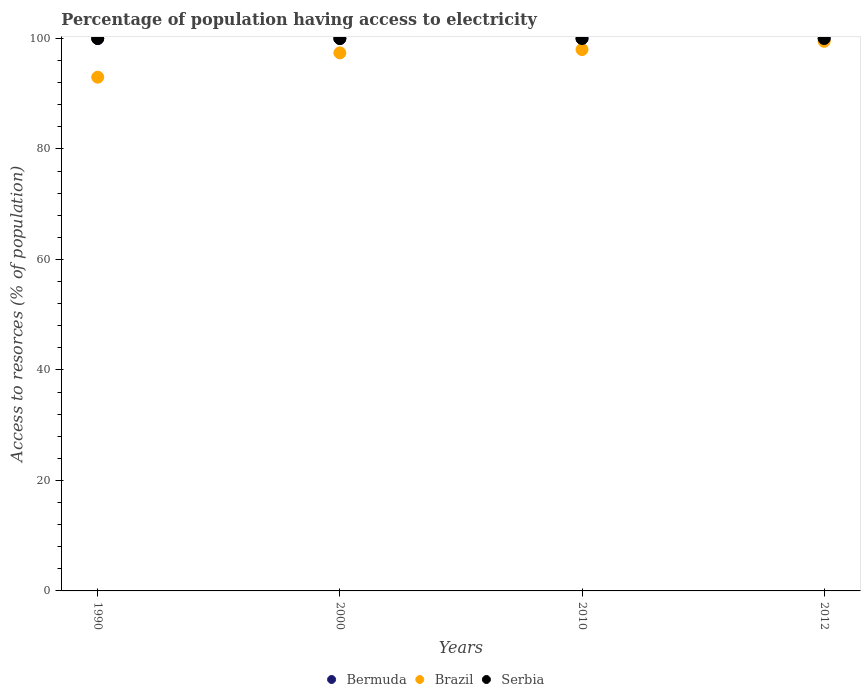How many different coloured dotlines are there?
Your answer should be very brief. 3. Is the number of dotlines equal to the number of legend labels?
Offer a very short reply. Yes. What is the percentage of population having access to electricity in Serbia in 2000?
Keep it short and to the point. 100. Across all years, what is the maximum percentage of population having access to electricity in Brazil?
Ensure brevity in your answer.  99.5. Across all years, what is the minimum percentage of population having access to electricity in Brazil?
Offer a very short reply. 93. In which year was the percentage of population having access to electricity in Serbia minimum?
Your answer should be compact. 1990. What is the total percentage of population having access to electricity in Brazil in the graph?
Provide a succinct answer. 387.9. What is the difference between the percentage of population having access to electricity in Brazil in 1990 and that in 2012?
Provide a succinct answer. -6.5. What is the difference between the percentage of population having access to electricity in Brazil in 1990 and the percentage of population having access to electricity in Bermuda in 2012?
Your answer should be very brief. -7. In the year 2000, what is the difference between the percentage of population having access to electricity in Serbia and percentage of population having access to electricity in Brazil?
Give a very brief answer. 2.6. What is the ratio of the percentage of population having access to electricity in Serbia in 2010 to that in 2012?
Your answer should be very brief. 1. Is the difference between the percentage of population having access to electricity in Serbia in 2010 and 2012 greater than the difference between the percentage of population having access to electricity in Brazil in 2010 and 2012?
Make the answer very short. Yes. What is the difference between the highest and the second highest percentage of population having access to electricity in Serbia?
Keep it short and to the point. 0. Is the percentage of population having access to electricity in Bermuda strictly greater than the percentage of population having access to electricity in Serbia over the years?
Give a very brief answer. No. Is the percentage of population having access to electricity in Bermuda strictly less than the percentage of population having access to electricity in Serbia over the years?
Your response must be concise. No. Are the values on the major ticks of Y-axis written in scientific E-notation?
Offer a very short reply. No. Does the graph contain grids?
Make the answer very short. No. How are the legend labels stacked?
Offer a very short reply. Horizontal. What is the title of the graph?
Your response must be concise. Percentage of population having access to electricity. What is the label or title of the X-axis?
Give a very brief answer. Years. What is the label or title of the Y-axis?
Your answer should be compact. Access to resorces (% of population). What is the Access to resorces (% of population) of Bermuda in 1990?
Offer a terse response. 100. What is the Access to resorces (% of population) in Brazil in 1990?
Provide a short and direct response. 93. What is the Access to resorces (% of population) in Serbia in 1990?
Offer a very short reply. 100. What is the Access to resorces (% of population) of Bermuda in 2000?
Your response must be concise. 100. What is the Access to resorces (% of population) of Brazil in 2000?
Give a very brief answer. 97.4. What is the Access to resorces (% of population) of Bermuda in 2012?
Your response must be concise. 100. What is the Access to resorces (% of population) in Brazil in 2012?
Your answer should be very brief. 99.5. What is the Access to resorces (% of population) of Serbia in 2012?
Your answer should be compact. 100. Across all years, what is the maximum Access to resorces (% of population) in Bermuda?
Your answer should be compact. 100. Across all years, what is the maximum Access to resorces (% of population) of Brazil?
Give a very brief answer. 99.5. Across all years, what is the maximum Access to resorces (% of population) of Serbia?
Keep it short and to the point. 100. Across all years, what is the minimum Access to resorces (% of population) in Brazil?
Make the answer very short. 93. Across all years, what is the minimum Access to resorces (% of population) in Serbia?
Ensure brevity in your answer.  100. What is the total Access to resorces (% of population) of Brazil in the graph?
Provide a short and direct response. 387.9. What is the difference between the Access to resorces (% of population) of Bermuda in 1990 and that in 2000?
Offer a terse response. 0. What is the difference between the Access to resorces (% of population) in Serbia in 1990 and that in 2000?
Offer a very short reply. 0. What is the difference between the Access to resorces (% of population) of Brazil in 1990 and that in 2010?
Make the answer very short. -5. What is the difference between the Access to resorces (% of population) of Bermuda in 1990 and that in 2012?
Offer a terse response. 0. What is the difference between the Access to resorces (% of population) in Brazil in 1990 and that in 2012?
Your answer should be very brief. -6.5. What is the difference between the Access to resorces (% of population) of Bermuda in 2000 and that in 2010?
Make the answer very short. 0. What is the difference between the Access to resorces (% of population) in Serbia in 2000 and that in 2010?
Provide a short and direct response. 0. What is the difference between the Access to resorces (% of population) of Bermuda in 2000 and that in 2012?
Give a very brief answer. 0. What is the difference between the Access to resorces (% of population) of Serbia in 2000 and that in 2012?
Provide a short and direct response. 0. What is the difference between the Access to resorces (% of population) of Bermuda in 2010 and that in 2012?
Your answer should be very brief. 0. What is the difference between the Access to resorces (% of population) of Brazil in 2010 and that in 2012?
Provide a succinct answer. -1.5. What is the difference between the Access to resorces (% of population) in Serbia in 2010 and that in 2012?
Make the answer very short. 0. What is the difference between the Access to resorces (% of population) in Bermuda in 1990 and the Access to resorces (% of population) in Brazil in 2000?
Provide a short and direct response. 2.6. What is the difference between the Access to resorces (% of population) in Bermuda in 1990 and the Access to resorces (% of population) in Brazil in 2010?
Offer a terse response. 2. What is the difference between the Access to resorces (% of population) in Bermuda in 1990 and the Access to resorces (% of population) in Serbia in 2012?
Your answer should be compact. 0. What is the difference between the Access to resorces (% of population) in Brazil in 1990 and the Access to resorces (% of population) in Serbia in 2012?
Give a very brief answer. -7. What is the average Access to resorces (% of population) of Brazil per year?
Offer a very short reply. 96.97. What is the average Access to resorces (% of population) of Serbia per year?
Offer a very short reply. 100. In the year 1990, what is the difference between the Access to resorces (% of population) in Bermuda and Access to resorces (% of population) in Serbia?
Offer a very short reply. 0. In the year 1990, what is the difference between the Access to resorces (% of population) in Brazil and Access to resorces (% of population) in Serbia?
Offer a very short reply. -7. In the year 2000, what is the difference between the Access to resorces (% of population) of Brazil and Access to resorces (% of population) of Serbia?
Keep it short and to the point. -2.6. In the year 2010, what is the difference between the Access to resorces (% of population) in Bermuda and Access to resorces (% of population) in Brazil?
Keep it short and to the point. 2. In the year 2010, what is the difference between the Access to resorces (% of population) in Bermuda and Access to resorces (% of population) in Serbia?
Provide a succinct answer. 0. In the year 2010, what is the difference between the Access to resorces (% of population) in Brazil and Access to resorces (% of population) in Serbia?
Ensure brevity in your answer.  -2. In the year 2012, what is the difference between the Access to resorces (% of population) of Bermuda and Access to resorces (% of population) of Brazil?
Your response must be concise. 0.5. In the year 2012, what is the difference between the Access to resorces (% of population) in Bermuda and Access to resorces (% of population) in Serbia?
Your response must be concise. 0. What is the ratio of the Access to resorces (% of population) of Brazil in 1990 to that in 2000?
Provide a succinct answer. 0.95. What is the ratio of the Access to resorces (% of population) in Bermuda in 1990 to that in 2010?
Make the answer very short. 1. What is the ratio of the Access to resorces (% of population) in Brazil in 1990 to that in 2010?
Your response must be concise. 0.95. What is the ratio of the Access to resorces (% of population) of Serbia in 1990 to that in 2010?
Give a very brief answer. 1. What is the ratio of the Access to resorces (% of population) in Brazil in 1990 to that in 2012?
Your response must be concise. 0.93. What is the ratio of the Access to resorces (% of population) of Brazil in 2000 to that in 2010?
Offer a terse response. 0.99. What is the ratio of the Access to resorces (% of population) of Serbia in 2000 to that in 2010?
Provide a short and direct response. 1. What is the ratio of the Access to resorces (% of population) in Bermuda in 2000 to that in 2012?
Provide a short and direct response. 1. What is the ratio of the Access to resorces (% of population) in Brazil in 2000 to that in 2012?
Keep it short and to the point. 0.98. What is the ratio of the Access to resorces (% of population) of Serbia in 2000 to that in 2012?
Give a very brief answer. 1. What is the ratio of the Access to resorces (% of population) of Brazil in 2010 to that in 2012?
Make the answer very short. 0.98. What is the difference between the highest and the second highest Access to resorces (% of population) in Brazil?
Your answer should be very brief. 1.5. What is the difference between the highest and the second highest Access to resorces (% of population) in Serbia?
Provide a short and direct response. 0. What is the difference between the highest and the lowest Access to resorces (% of population) of Bermuda?
Provide a short and direct response. 0. 